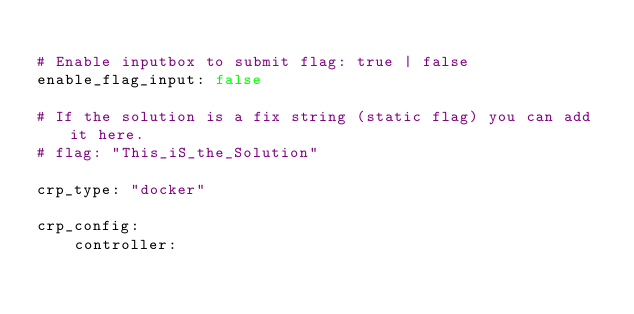Convert code to text. <code><loc_0><loc_0><loc_500><loc_500><_YAML_>
# Enable inputbox to submit flag: true | false
enable_flag_input: false

# If the solution is a fix string (static flag) you can add it here.
# flag: "This_iS_the_Solution"

crp_type: "docker"

crp_config:
    controller:</code> 